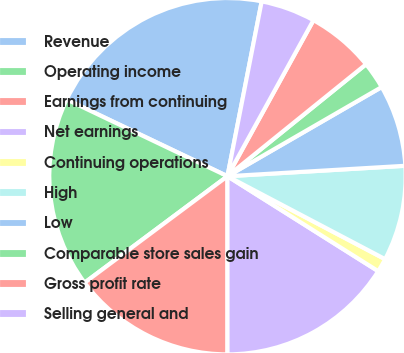<chart> <loc_0><loc_0><loc_500><loc_500><pie_chart><fcel>Revenue<fcel>Operating income<fcel>Earnings from continuing<fcel>Net earnings<fcel>Continuing operations<fcel>High<fcel>Low<fcel>Comparable store sales gain<fcel>Gross profit rate<fcel>Selling general and<nl><fcel>20.99%<fcel>17.28%<fcel>14.81%<fcel>16.05%<fcel>1.24%<fcel>8.64%<fcel>7.41%<fcel>2.47%<fcel>6.17%<fcel>4.94%<nl></chart> 